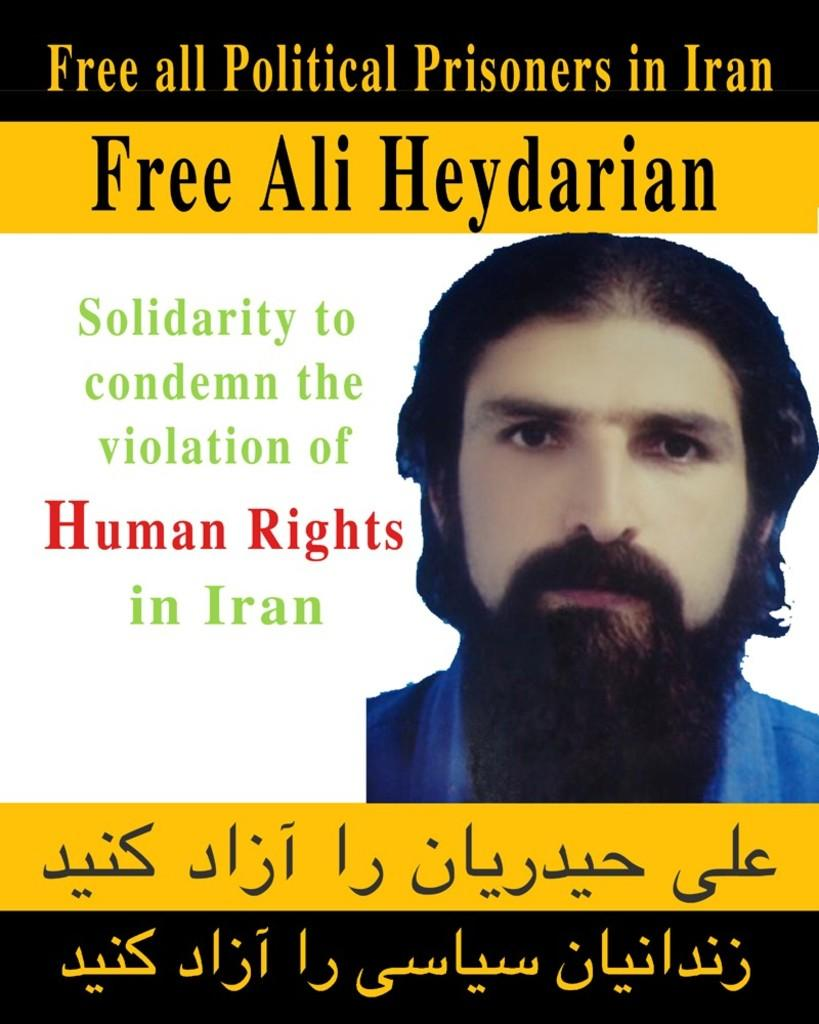What is present on the left side of the image? There is a poster in the image. What can be seen on the right side of the poster? There is an image of a man on the right side of the poster. What is featured on the poster besides the image of the man? Text or matter is written on the poster. Can you tell me what time the person is watching on the watch in the image? There is no person or watch present in the image; it features a poster with an image of a man and text. 